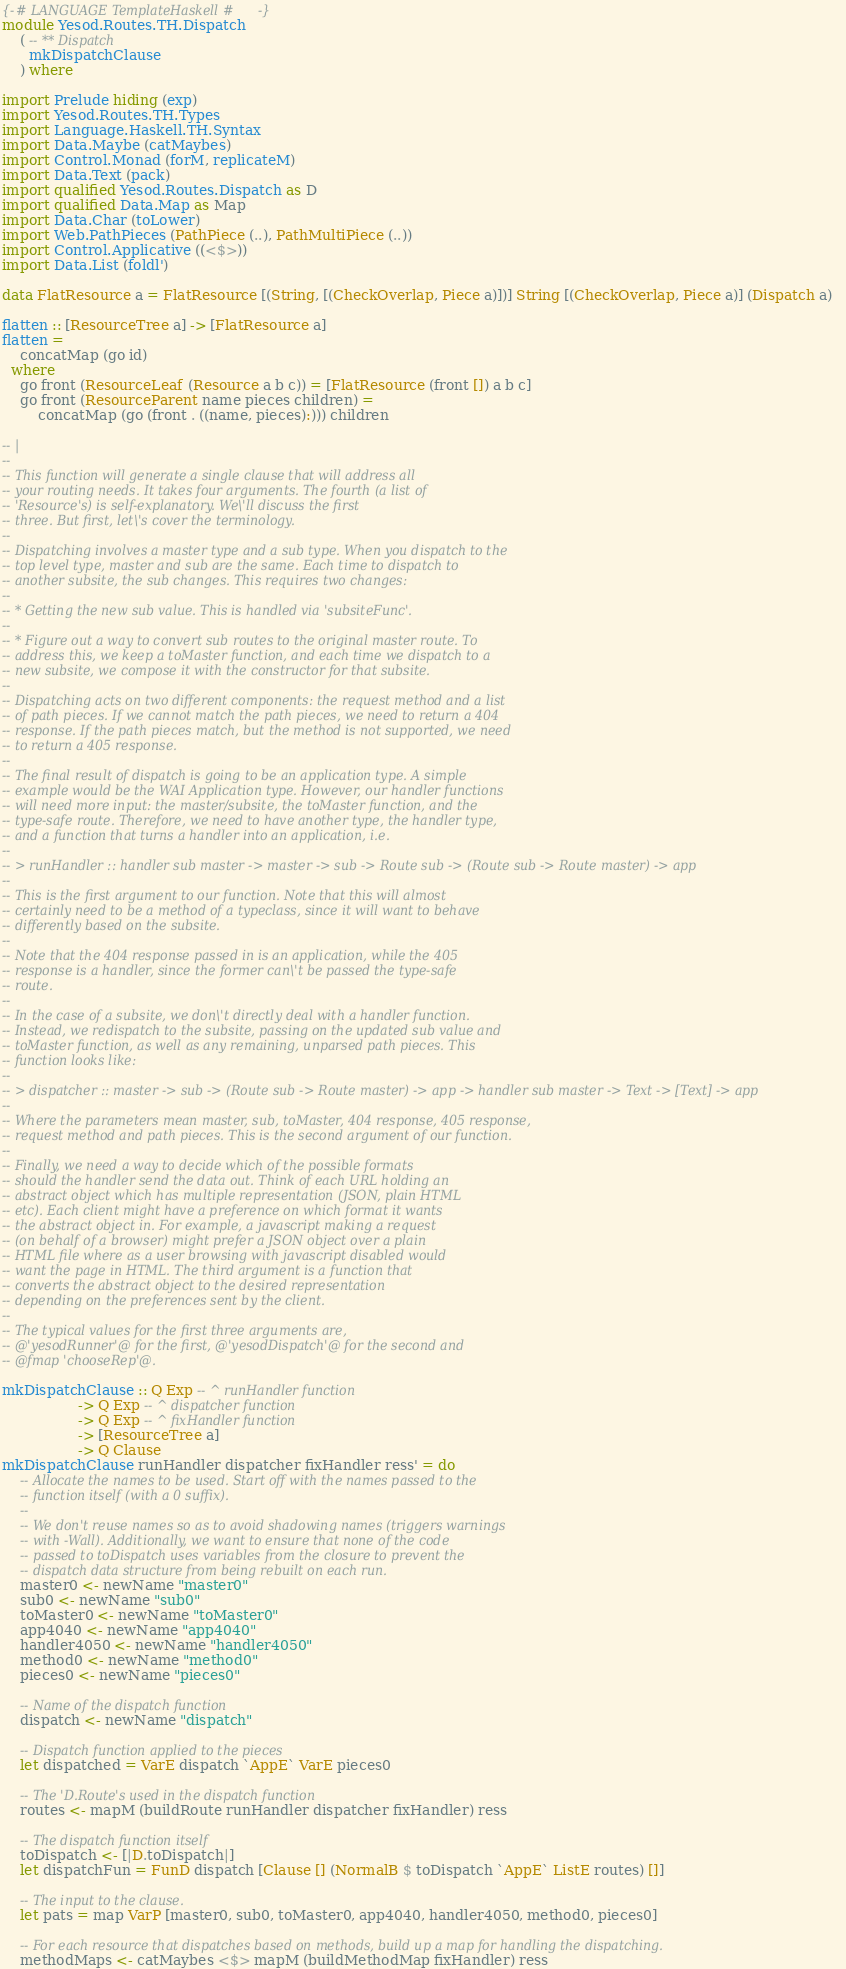Convert code to text. <code><loc_0><loc_0><loc_500><loc_500><_Haskell_>{-# LANGUAGE TemplateHaskell #-}
module Yesod.Routes.TH.Dispatch
    ( -- ** Dispatch
      mkDispatchClause
    ) where

import Prelude hiding (exp)
import Yesod.Routes.TH.Types
import Language.Haskell.TH.Syntax
import Data.Maybe (catMaybes)
import Control.Monad (forM, replicateM)
import Data.Text (pack)
import qualified Yesod.Routes.Dispatch as D
import qualified Data.Map as Map
import Data.Char (toLower)
import Web.PathPieces (PathPiece (..), PathMultiPiece (..))
import Control.Applicative ((<$>))
import Data.List (foldl')

data FlatResource a = FlatResource [(String, [(CheckOverlap, Piece a)])] String [(CheckOverlap, Piece a)] (Dispatch a)

flatten :: [ResourceTree a] -> [FlatResource a]
flatten =
    concatMap (go id)
  where
    go front (ResourceLeaf (Resource a b c)) = [FlatResource (front []) a b c]
    go front (ResourceParent name pieces children) =
        concatMap (go (front . ((name, pieces):))) children

-- |
--
-- This function will generate a single clause that will address all
-- your routing needs. It takes four arguments. The fourth (a list of
-- 'Resource's) is self-explanatory. We\'ll discuss the first
-- three. But first, let\'s cover the terminology.
--
-- Dispatching involves a master type and a sub type. When you dispatch to the
-- top level type, master and sub are the same. Each time to dispatch to
-- another subsite, the sub changes. This requires two changes:
--
-- * Getting the new sub value. This is handled via 'subsiteFunc'.
--
-- * Figure out a way to convert sub routes to the original master route. To
-- address this, we keep a toMaster function, and each time we dispatch to a
-- new subsite, we compose it with the constructor for that subsite.
--
-- Dispatching acts on two different components: the request method and a list
-- of path pieces. If we cannot match the path pieces, we need to return a 404
-- response. If the path pieces match, but the method is not supported, we need
-- to return a 405 response.
--
-- The final result of dispatch is going to be an application type. A simple
-- example would be the WAI Application type. However, our handler functions
-- will need more input: the master/subsite, the toMaster function, and the
-- type-safe route. Therefore, we need to have another type, the handler type,
-- and a function that turns a handler into an application, i.e.
--
-- > runHandler :: handler sub master -> master -> sub -> Route sub -> (Route sub -> Route master) -> app
--
-- This is the first argument to our function. Note that this will almost
-- certainly need to be a method of a typeclass, since it will want to behave
-- differently based on the subsite.
--
-- Note that the 404 response passed in is an application, while the 405
-- response is a handler, since the former can\'t be passed the type-safe
-- route.
--
-- In the case of a subsite, we don\'t directly deal with a handler function.
-- Instead, we redispatch to the subsite, passing on the updated sub value and
-- toMaster function, as well as any remaining, unparsed path pieces. This
-- function looks like:
--
-- > dispatcher :: master -> sub -> (Route sub -> Route master) -> app -> handler sub master -> Text -> [Text] -> app
--
-- Where the parameters mean master, sub, toMaster, 404 response, 405 response,
-- request method and path pieces. This is the second argument of our function.
--
-- Finally, we need a way to decide which of the possible formats
-- should the handler send the data out. Think of each URL holding an
-- abstract object which has multiple representation (JSON, plain HTML
-- etc). Each client might have a preference on which format it wants
-- the abstract object in. For example, a javascript making a request
-- (on behalf of a browser) might prefer a JSON object over a plain
-- HTML file where as a user browsing with javascript disabled would
-- want the page in HTML. The third argument is a function that
-- converts the abstract object to the desired representation
-- depending on the preferences sent by the client.
--
-- The typical values for the first three arguments are,
-- @'yesodRunner'@ for the first, @'yesodDispatch'@ for the second and
-- @fmap 'chooseRep'@.

mkDispatchClause :: Q Exp -- ^ runHandler function
                 -> Q Exp -- ^ dispatcher function
                 -> Q Exp -- ^ fixHandler function
                 -> [ResourceTree a]
                 -> Q Clause
mkDispatchClause runHandler dispatcher fixHandler ress' = do
    -- Allocate the names to be used. Start off with the names passed to the
    -- function itself (with a 0 suffix).
    --
    -- We don't reuse names so as to avoid shadowing names (triggers warnings
    -- with -Wall). Additionally, we want to ensure that none of the code
    -- passed to toDispatch uses variables from the closure to prevent the
    -- dispatch data structure from being rebuilt on each run.
    master0 <- newName "master0"
    sub0 <- newName "sub0"
    toMaster0 <- newName "toMaster0"
    app4040 <- newName "app4040"
    handler4050 <- newName "handler4050"
    method0 <- newName "method0"
    pieces0 <- newName "pieces0"

    -- Name of the dispatch function
    dispatch <- newName "dispatch"

    -- Dispatch function applied to the pieces
    let dispatched = VarE dispatch `AppE` VarE pieces0

    -- The 'D.Route's used in the dispatch function
    routes <- mapM (buildRoute runHandler dispatcher fixHandler) ress

    -- The dispatch function itself
    toDispatch <- [|D.toDispatch|]
    let dispatchFun = FunD dispatch [Clause [] (NormalB $ toDispatch `AppE` ListE routes) []]

    -- The input to the clause.
    let pats = map VarP [master0, sub0, toMaster0, app4040, handler4050, method0, pieces0]

    -- For each resource that dispatches based on methods, build up a map for handling the dispatching.
    methodMaps <- catMaybes <$> mapM (buildMethodMap fixHandler) ress
</code> 